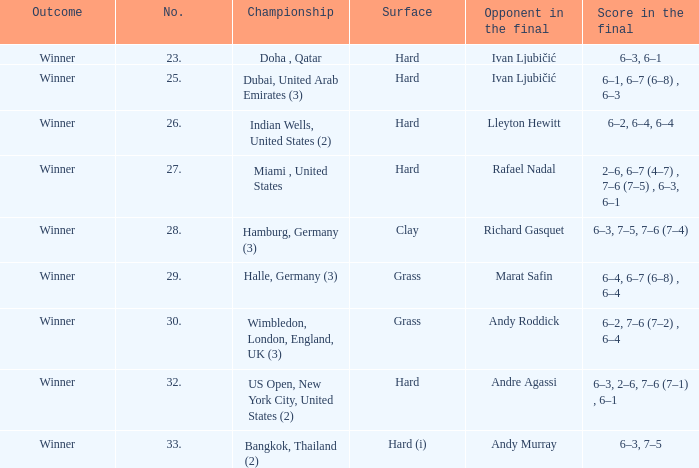Andy roddick is the competitor in the final on which surface? Grass. Write the full table. {'header': ['Outcome', 'No.', 'Championship', 'Surface', 'Opponent in the final', 'Score in the final'], 'rows': [['Winner', '23.', 'Doha , Qatar', 'Hard', 'Ivan Ljubičić', '6–3, 6–1'], ['Winner', '25.', 'Dubai, United Arab Emirates (3)', 'Hard', 'Ivan Ljubičić', '6–1, 6–7 (6–8) , 6–3'], ['Winner', '26.', 'Indian Wells, United States (2)', 'Hard', 'Lleyton Hewitt', '6–2, 6–4, 6–4'], ['Winner', '27.', 'Miami , United States', 'Hard', 'Rafael Nadal', '2–6, 6–7 (4–7) , 7–6 (7–5) , 6–3, 6–1'], ['Winner', '28.', 'Hamburg, Germany (3)', 'Clay', 'Richard Gasquet', '6–3, 7–5, 7–6 (7–4)'], ['Winner', '29.', 'Halle, Germany (3)', 'Grass', 'Marat Safin', '6–4, 6–7 (6–8) , 6–4'], ['Winner', '30.', 'Wimbledon, London, England, UK (3)', 'Grass', 'Andy Roddick', '6–2, 7–6 (7–2) , 6–4'], ['Winner', '32.', 'US Open, New York City, United States (2)', 'Hard', 'Andre Agassi', '6–3, 2–6, 7–6 (7–1) , 6–1'], ['Winner', '33.', 'Bangkok, Thailand (2)', 'Hard (i)', 'Andy Murray', '6–3, 7–5']]} 